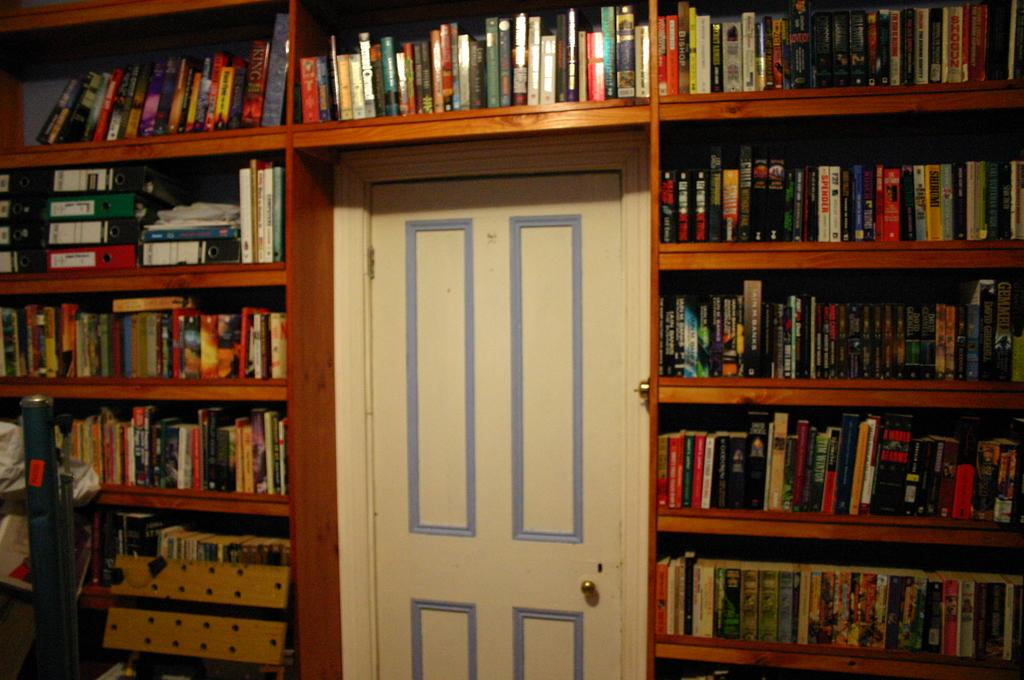What type of items can be seen in the book shelf in the image? There are books in the book shelf in the image. What architectural feature is present in the image? There is a door in the image. What is the color of the door? The door is white in color. What type of scene is depicted on the sail in the image? There is no sail present in the image; it features a door and a book shelf. How is the door connected to the books in the image? The door and the books are separate objects in the image, and there is no direct connection between them. 